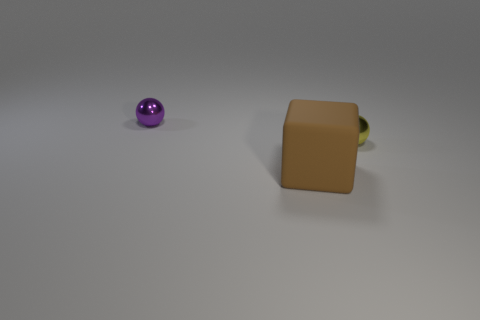Subtract all cyan balls. Subtract all gray cylinders. How many balls are left? 2 Add 1 small purple spheres. How many objects exist? 4 Subtract all balls. How many objects are left? 1 Add 1 small purple metallic objects. How many small purple metallic objects are left? 2 Add 3 tiny yellow metal cubes. How many tiny yellow metal cubes exist? 3 Subtract 1 purple spheres. How many objects are left? 2 Subtract all tiny gray metallic cubes. Subtract all small things. How many objects are left? 1 